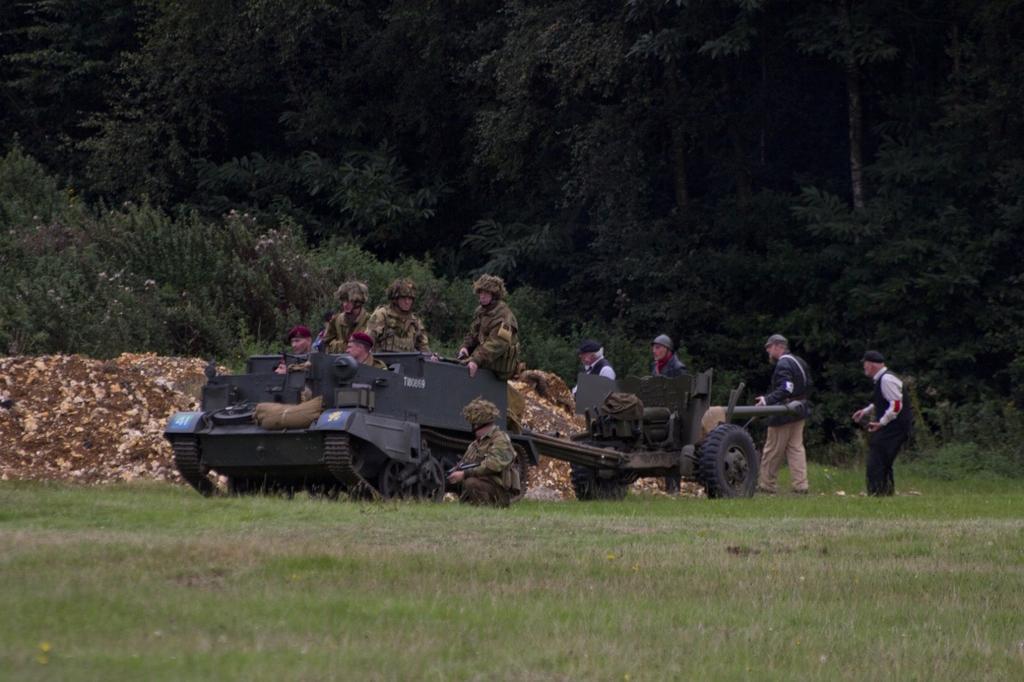Could you give a brief overview of what you see in this image? This image is clicked outside. There are trees on the top. There is grass in the bottom. There are so many soldiers sitting in a vehicle. Back side there are some persons. Soldiers are wearing military dresses. Other people they are wearing black color dress. 